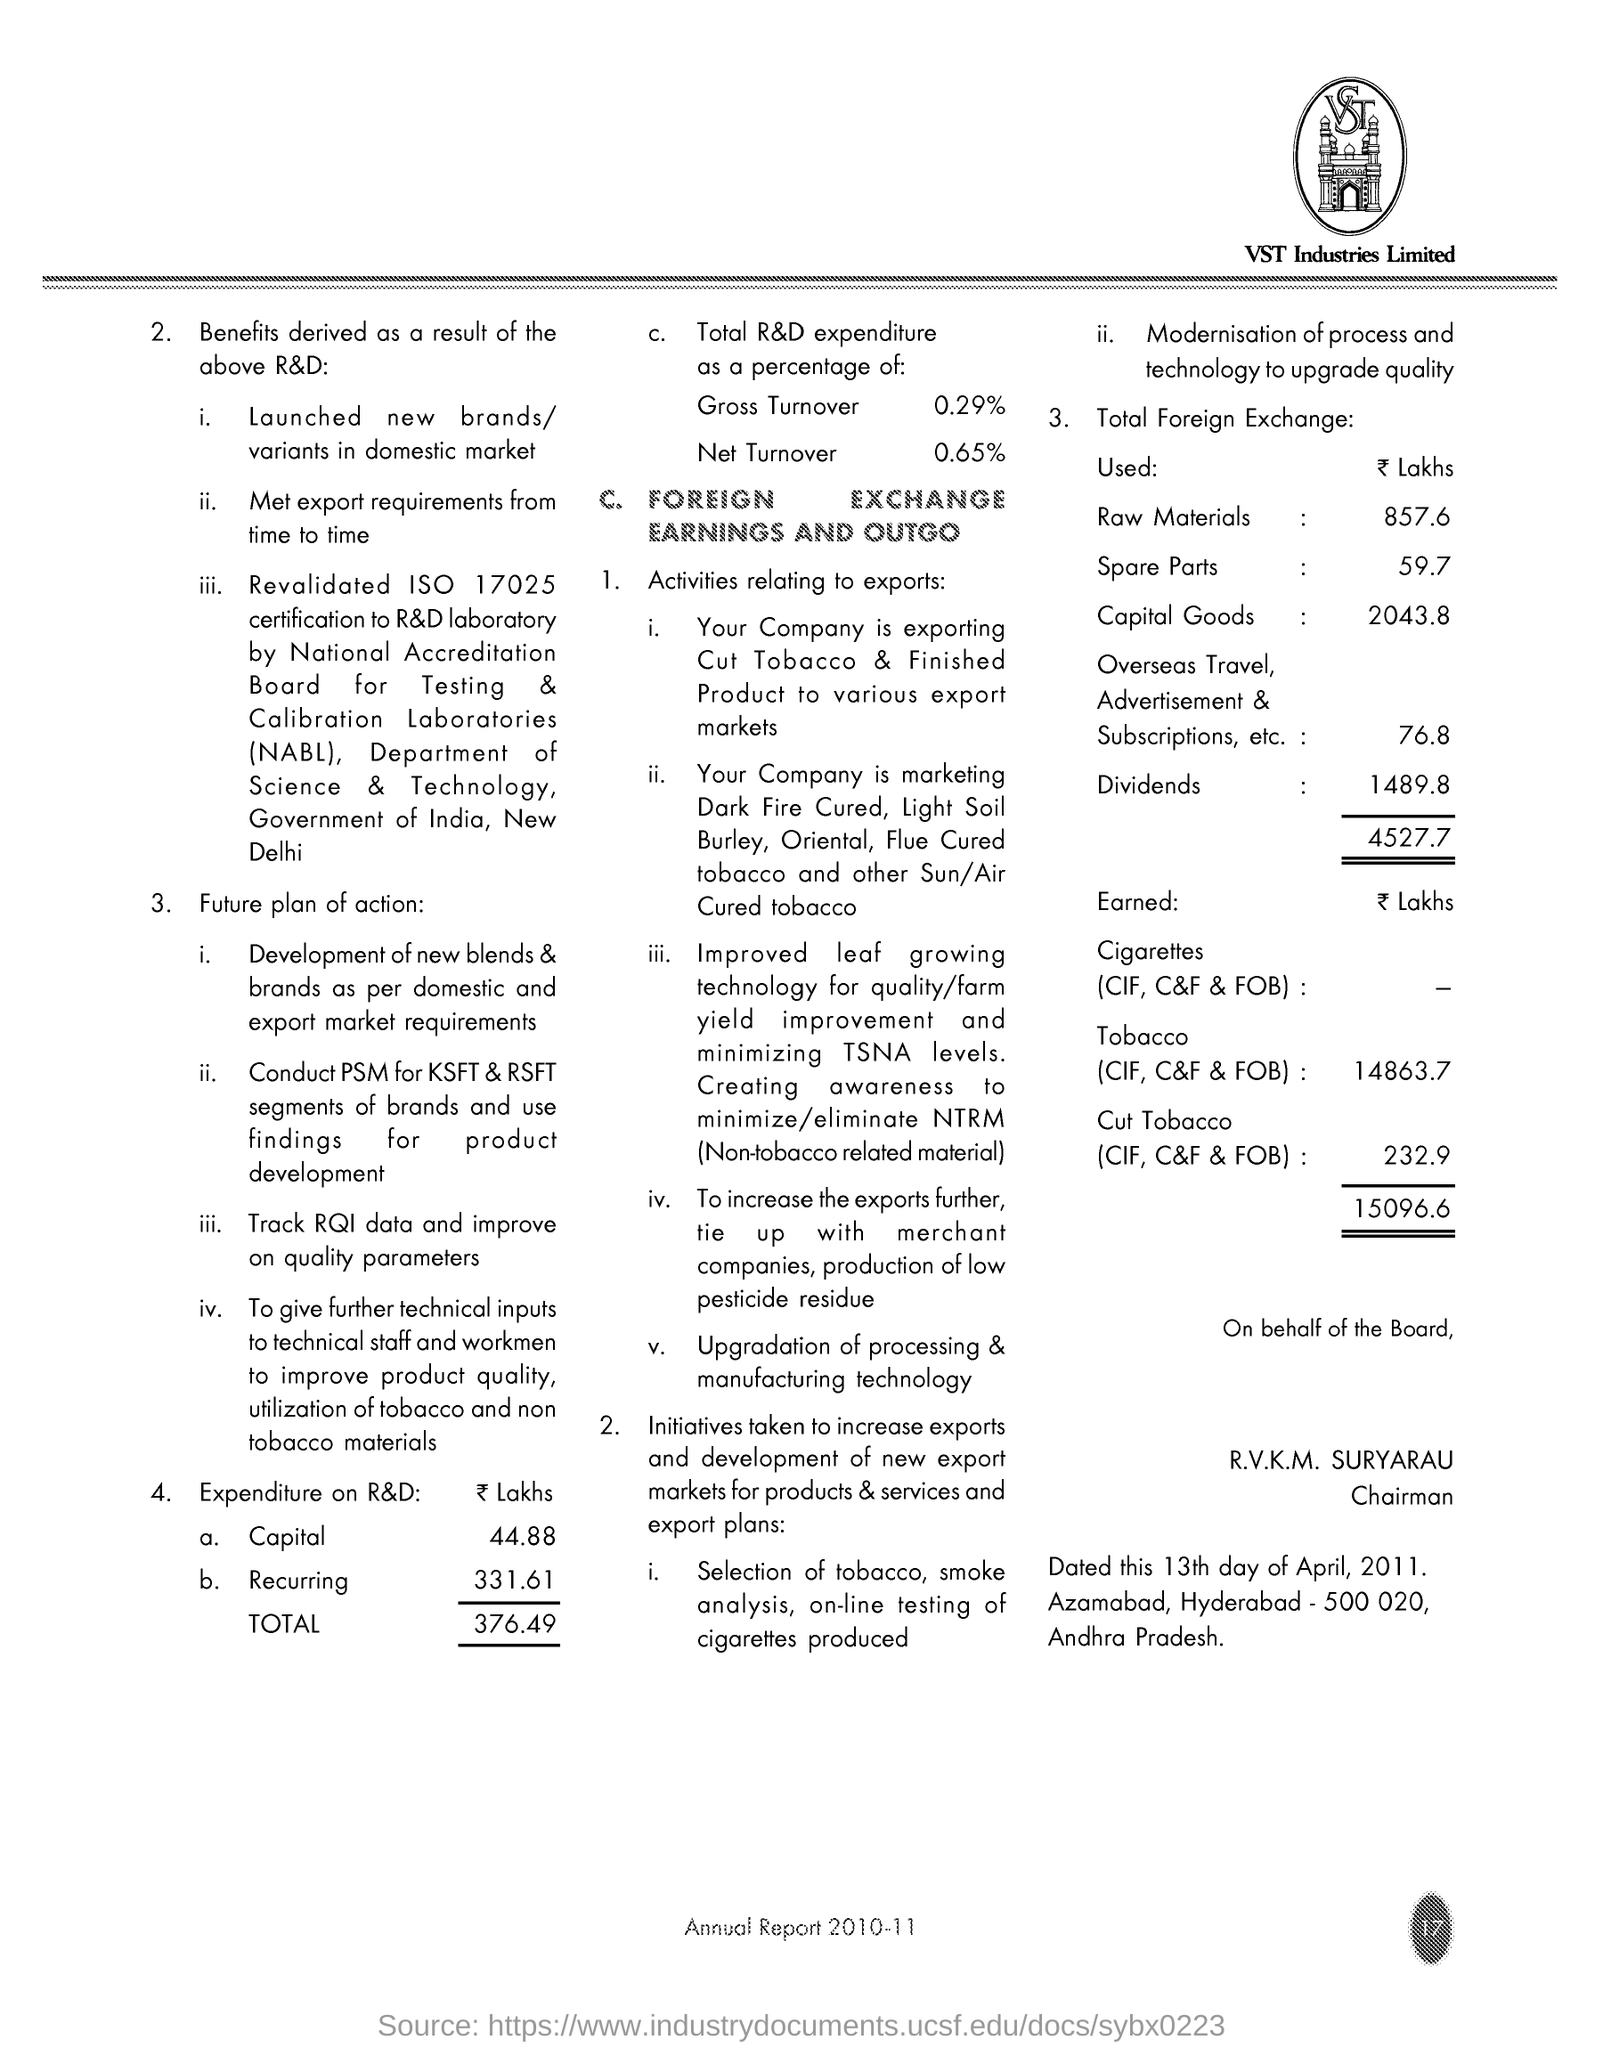Draw attention to some important aspects in this diagram. Recurring expenditure is an expense that is incurred repeatedly over a period of time, such as a monthly or yearly expenditure. An example of a recurring expenditure is a car loan payment of $331.61 per month. What is an ISO number revalidated? It is 17025. The total expenditure is 376.49 lakhs. The percentage of net turnover is 0.65. The amount of capital is 44.88 lakhs. 